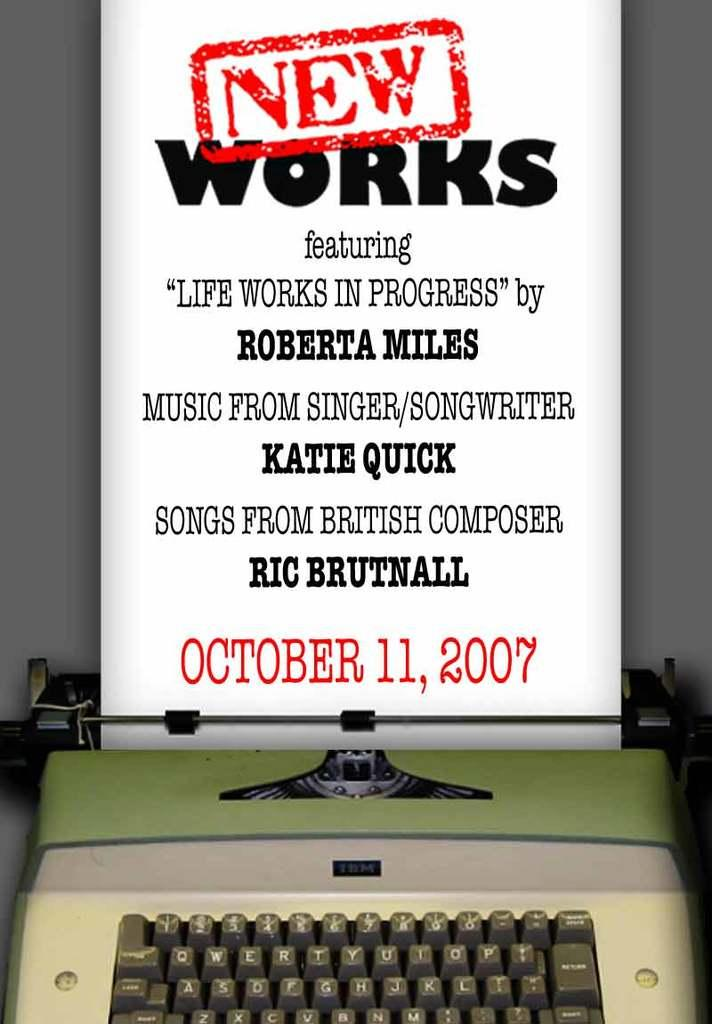Provide a one-sentence caption for the provided image. Typewriter with an ad above it that says "New Works". 